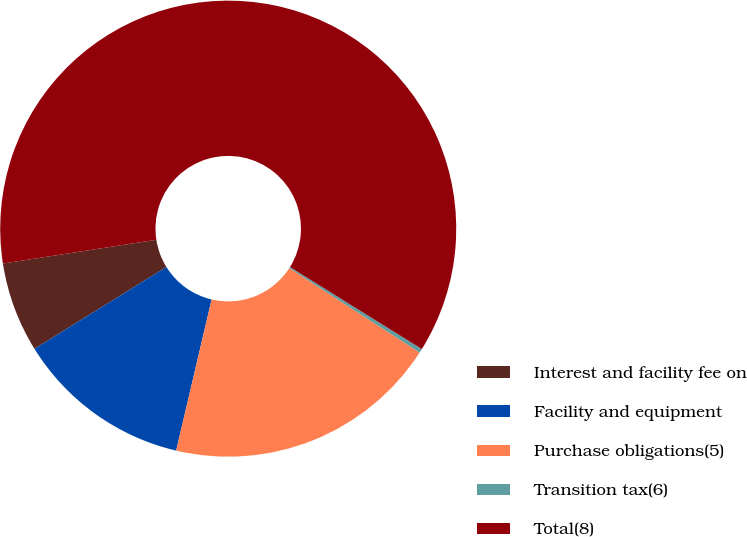Convert chart to OTSL. <chart><loc_0><loc_0><loc_500><loc_500><pie_chart><fcel>Interest and facility fee on<fcel>Facility and equipment<fcel>Purchase obligations(5)<fcel>Transition tax(6)<fcel>Total(8)<nl><fcel>6.39%<fcel>12.5%<fcel>19.52%<fcel>0.29%<fcel>61.3%<nl></chart> 